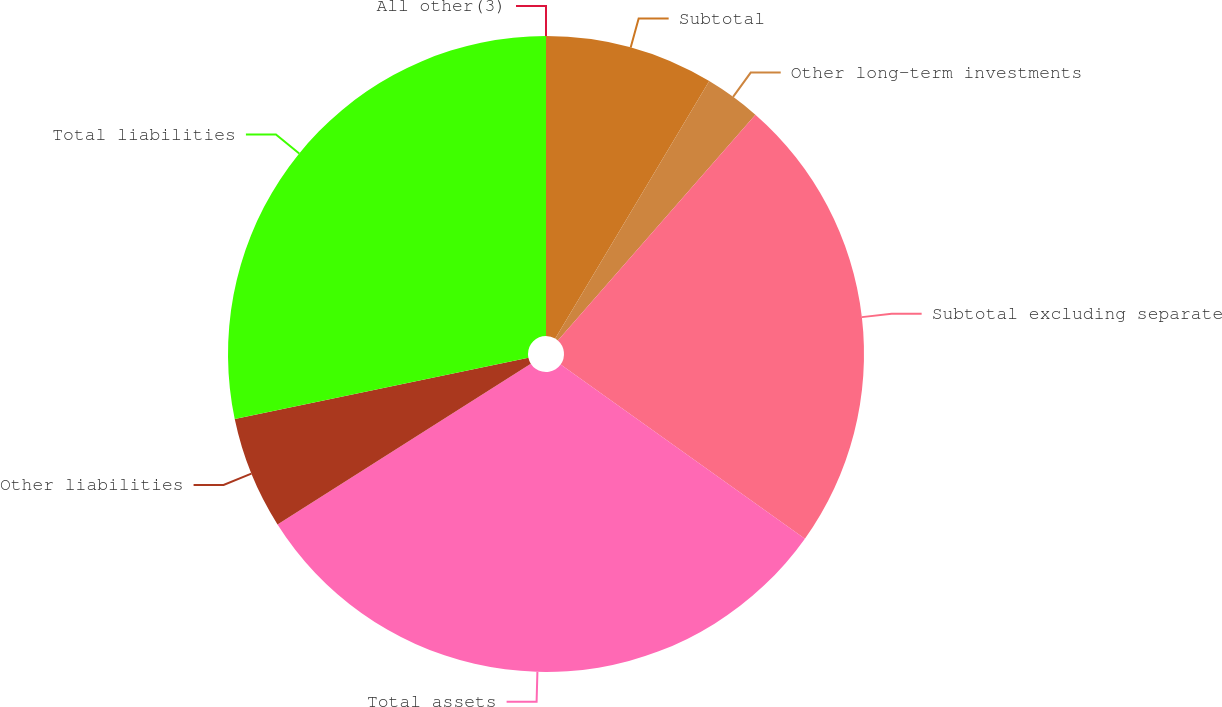<chart> <loc_0><loc_0><loc_500><loc_500><pie_chart><fcel>All other(3)<fcel>Subtotal<fcel>Other long-term investments<fcel>Subtotal excluding separate<fcel>Total assets<fcel>Other liabilities<fcel>Total liabilities<nl><fcel>0.0%<fcel>8.58%<fcel>2.86%<fcel>23.42%<fcel>31.14%<fcel>5.72%<fcel>28.28%<nl></chart> 